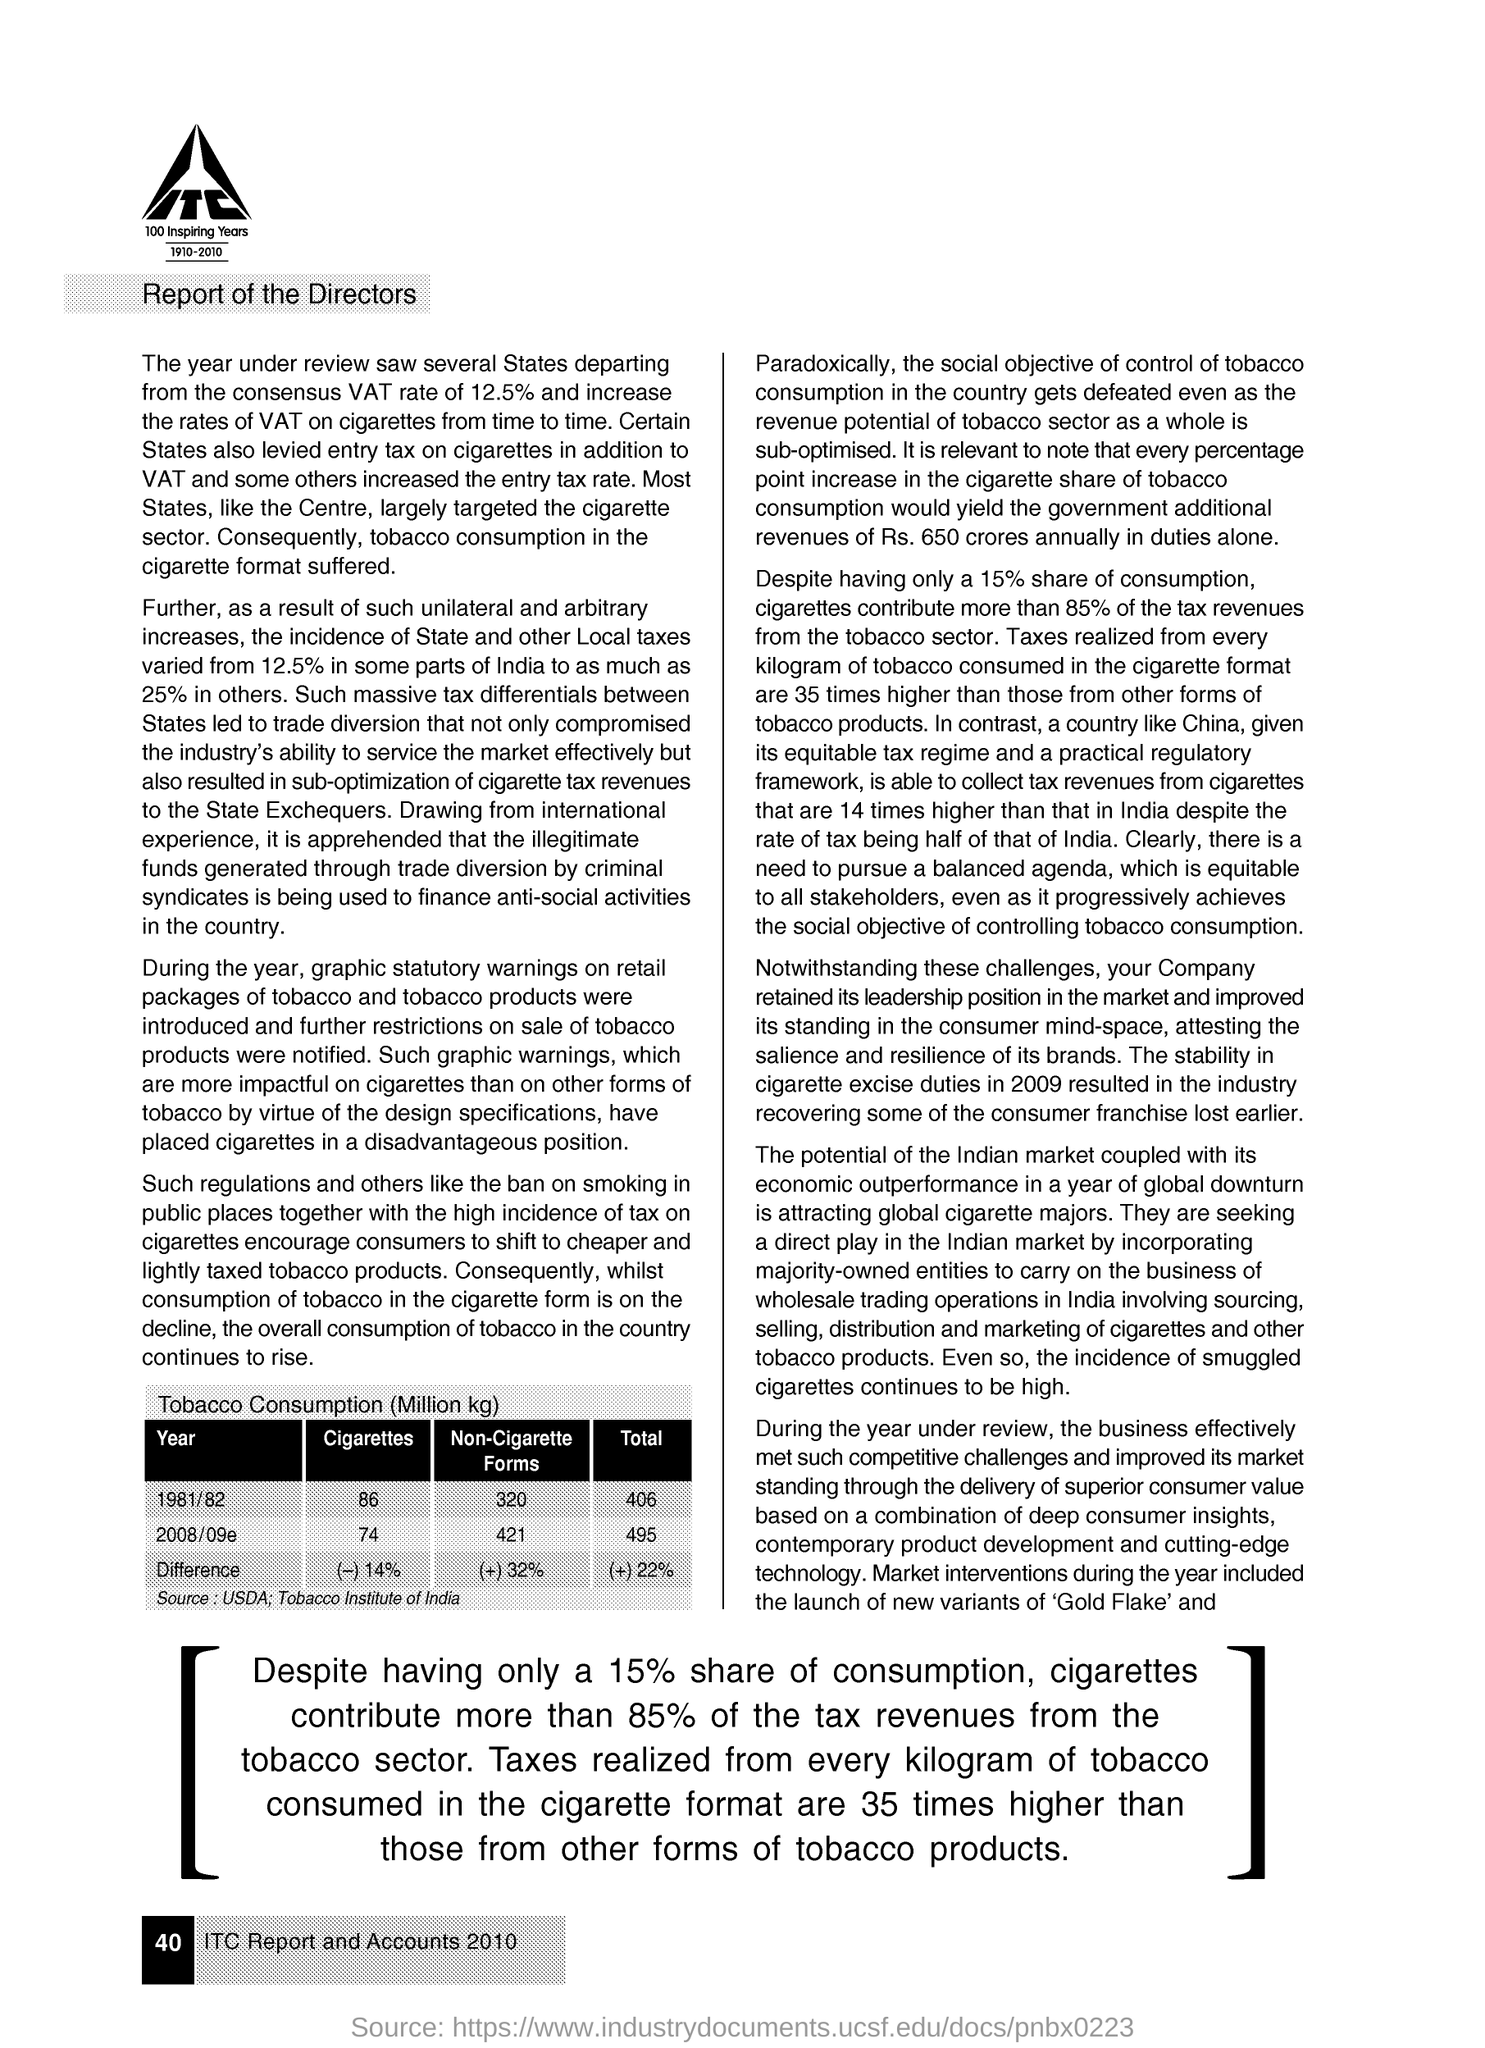Give some essential details in this illustration. The difference in the risk of having a stroke between people who do not consume cigarette forms and those who consume non-cigarette forms is mentioned to be around +32%. The difference in cigarette consumption is stated as -14%. 